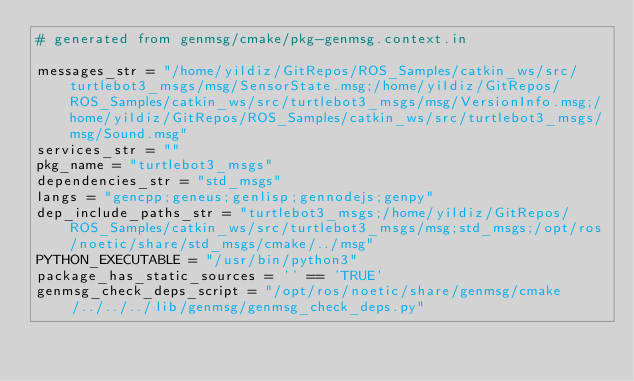<code> <loc_0><loc_0><loc_500><loc_500><_Python_># generated from genmsg/cmake/pkg-genmsg.context.in

messages_str = "/home/yildiz/GitRepos/ROS_Samples/catkin_ws/src/turtlebot3_msgs/msg/SensorState.msg;/home/yildiz/GitRepos/ROS_Samples/catkin_ws/src/turtlebot3_msgs/msg/VersionInfo.msg;/home/yildiz/GitRepos/ROS_Samples/catkin_ws/src/turtlebot3_msgs/msg/Sound.msg"
services_str = ""
pkg_name = "turtlebot3_msgs"
dependencies_str = "std_msgs"
langs = "gencpp;geneus;genlisp;gennodejs;genpy"
dep_include_paths_str = "turtlebot3_msgs;/home/yildiz/GitRepos/ROS_Samples/catkin_ws/src/turtlebot3_msgs/msg;std_msgs;/opt/ros/noetic/share/std_msgs/cmake/../msg"
PYTHON_EXECUTABLE = "/usr/bin/python3"
package_has_static_sources = '' == 'TRUE'
genmsg_check_deps_script = "/opt/ros/noetic/share/genmsg/cmake/../../../lib/genmsg/genmsg_check_deps.py"
</code> 